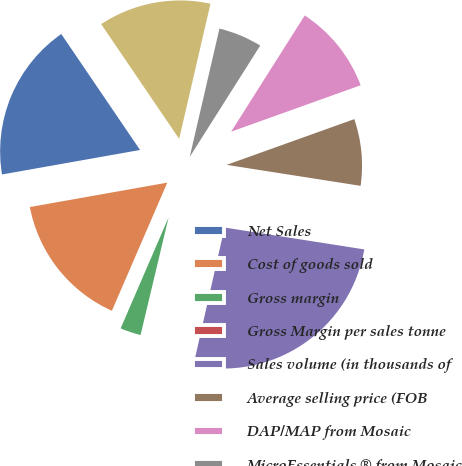Convert chart to OTSL. <chart><loc_0><loc_0><loc_500><loc_500><pie_chart><fcel>Net Sales<fcel>Cost of goods sold<fcel>Gross margin<fcel>Gross Margin per sales tonne<fcel>Sales volume (in thousands of<fcel>Average selling price (FOB<fcel>DAP/MAP from Mosaic<fcel>MicroEssentials ® from Mosaic<fcel>Potash from Mosaic/Canpotex<nl><fcel>18.3%<fcel>15.71%<fcel>2.77%<fcel>0.18%<fcel>26.07%<fcel>7.95%<fcel>10.54%<fcel>5.36%<fcel>13.12%<nl></chart> 